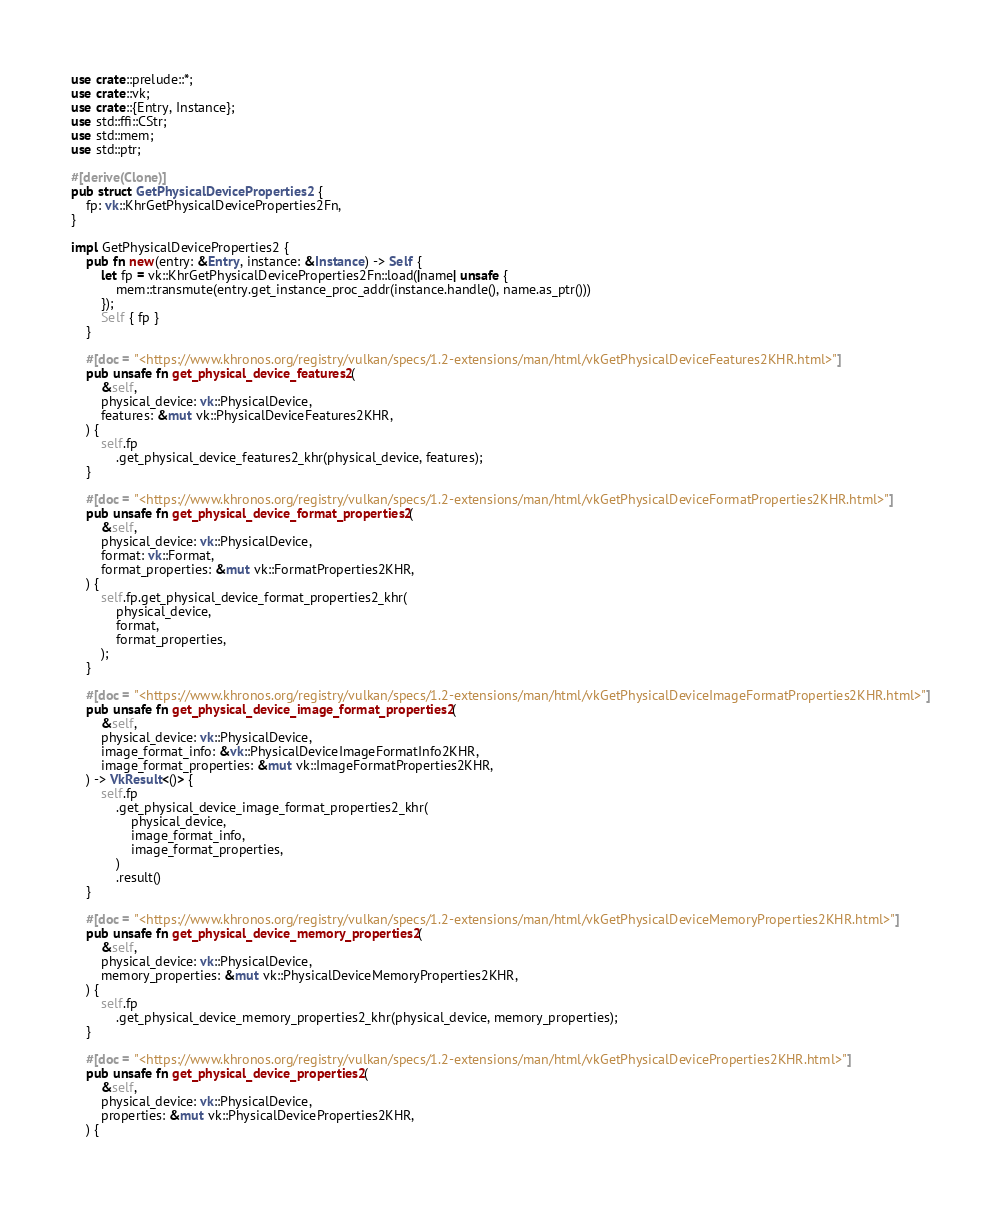Convert code to text. <code><loc_0><loc_0><loc_500><loc_500><_Rust_>use crate::prelude::*;
use crate::vk;
use crate::{Entry, Instance};
use std::ffi::CStr;
use std::mem;
use std::ptr;

#[derive(Clone)]
pub struct GetPhysicalDeviceProperties2 {
    fp: vk::KhrGetPhysicalDeviceProperties2Fn,
}

impl GetPhysicalDeviceProperties2 {
    pub fn new(entry: &Entry, instance: &Instance) -> Self {
        let fp = vk::KhrGetPhysicalDeviceProperties2Fn::load(|name| unsafe {
            mem::transmute(entry.get_instance_proc_addr(instance.handle(), name.as_ptr()))
        });
        Self { fp }
    }

    #[doc = "<https://www.khronos.org/registry/vulkan/specs/1.2-extensions/man/html/vkGetPhysicalDeviceFeatures2KHR.html>"]
    pub unsafe fn get_physical_device_features2(
        &self,
        physical_device: vk::PhysicalDevice,
        features: &mut vk::PhysicalDeviceFeatures2KHR,
    ) {
        self.fp
            .get_physical_device_features2_khr(physical_device, features);
    }

    #[doc = "<https://www.khronos.org/registry/vulkan/specs/1.2-extensions/man/html/vkGetPhysicalDeviceFormatProperties2KHR.html>"]
    pub unsafe fn get_physical_device_format_properties2(
        &self,
        physical_device: vk::PhysicalDevice,
        format: vk::Format,
        format_properties: &mut vk::FormatProperties2KHR,
    ) {
        self.fp.get_physical_device_format_properties2_khr(
            physical_device,
            format,
            format_properties,
        );
    }

    #[doc = "<https://www.khronos.org/registry/vulkan/specs/1.2-extensions/man/html/vkGetPhysicalDeviceImageFormatProperties2KHR.html>"]
    pub unsafe fn get_physical_device_image_format_properties2(
        &self,
        physical_device: vk::PhysicalDevice,
        image_format_info: &vk::PhysicalDeviceImageFormatInfo2KHR,
        image_format_properties: &mut vk::ImageFormatProperties2KHR,
    ) -> VkResult<()> {
        self.fp
            .get_physical_device_image_format_properties2_khr(
                physical_device,
                image_format_info,
                image_format_properties,
            )
            .result()
    }

    #[doc = "<https://www.khronos.org/registry/vulkan/specs/1.2-extensions/man/html/vkGetPhysicalDeviceMemoryProperties2KHR.html>"]
    pub unsafe fn get_physical_device_memory_properties2(
        &self,
        physical_device: vk::PhysicalDevice,
        memory_properties: &mut vk::PhysicalDeviceMemoryProperties2KHR,
    ) {
        self.fp
            .get_physical_device_memory_properties2_khr(physical_device, memory_properties);
    }

    #[doc = "<https://www.khronos.org/registry/vulkan/specs/1.2-extensions/man/html/vkGetPhysicalDeviceProperties2KHR.html>"]
    pub unsafe fn get_physical_device_properties2(
        &self,
        physical_device: vk::PhysicalDevice,
        properties: &mut vk::PhysicalDeviceProperties2KHR,
    ) {</code> 